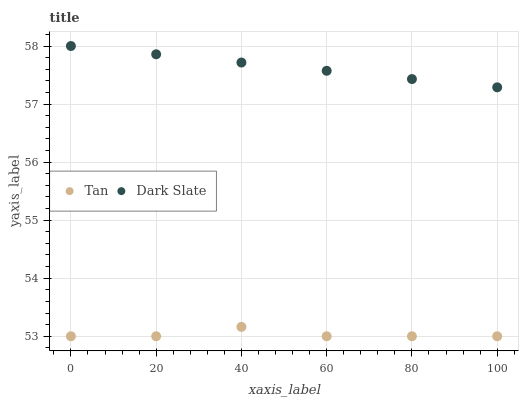Does Tan have the minimum area under the curve?
Answer yes or no. Yes. Does Dark Slate have the maximum area under the curve?
Answer yes or no. Yes. Does Tan have the maximum area under the curve?
Answer yes or no. No. Is Dark Slate the smoothest?
Answer yes or no. Yes. Is Tan the roughest?
Answer yes or no. Yes. Is Tan the smoothest?
Answer yes or no. No. Does Tan have the lowest value?
Answer yes or no. Yes. Does Dark Slate have the highest value?
Answer yes or no. Yes. Does Tan have the highest value?
Answer yes or no. No. Is Tan less than Dark Slate?
Answer yes or no. Yes. Is Dark Slate greater than Tan?
Answer yes or no. Yes. Does Tan intersect Dark Slate?
Answer yes or no. No. 